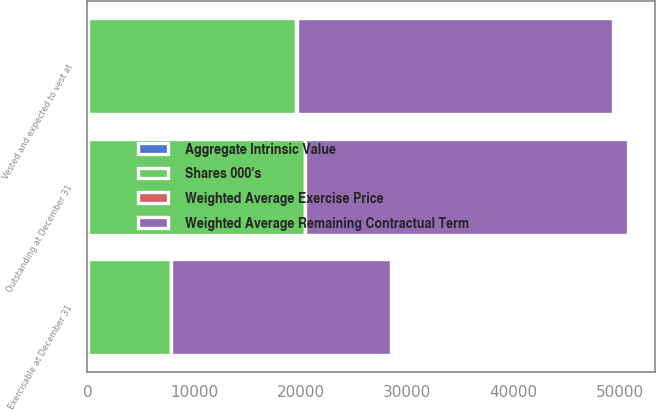Convert chart to OTSL. <chart><loc_0><loc_0><loc_500><loc_500><stacked_bar_chart><ecel><fcel>Outstanding at December 31<fcel>Vested and expected to vest at<fcel>Exercisable at December 31<nl><fcel>Weighted Average Remaining Contractual Term<fcel>30320<fcel>29686<fcel>20631<nl><fcel>Aggregate Intrinsic Value<fcel>20.18<fcel>20.4<fcel>24.34<nl><fcel>Weighted Average Exercise Price<fcel>3.07<fcel>3<fcel>1.89<nl><fcel>Shares 000's<fcel>20384<fcel>19607<fcel>7821<nl></chart> 